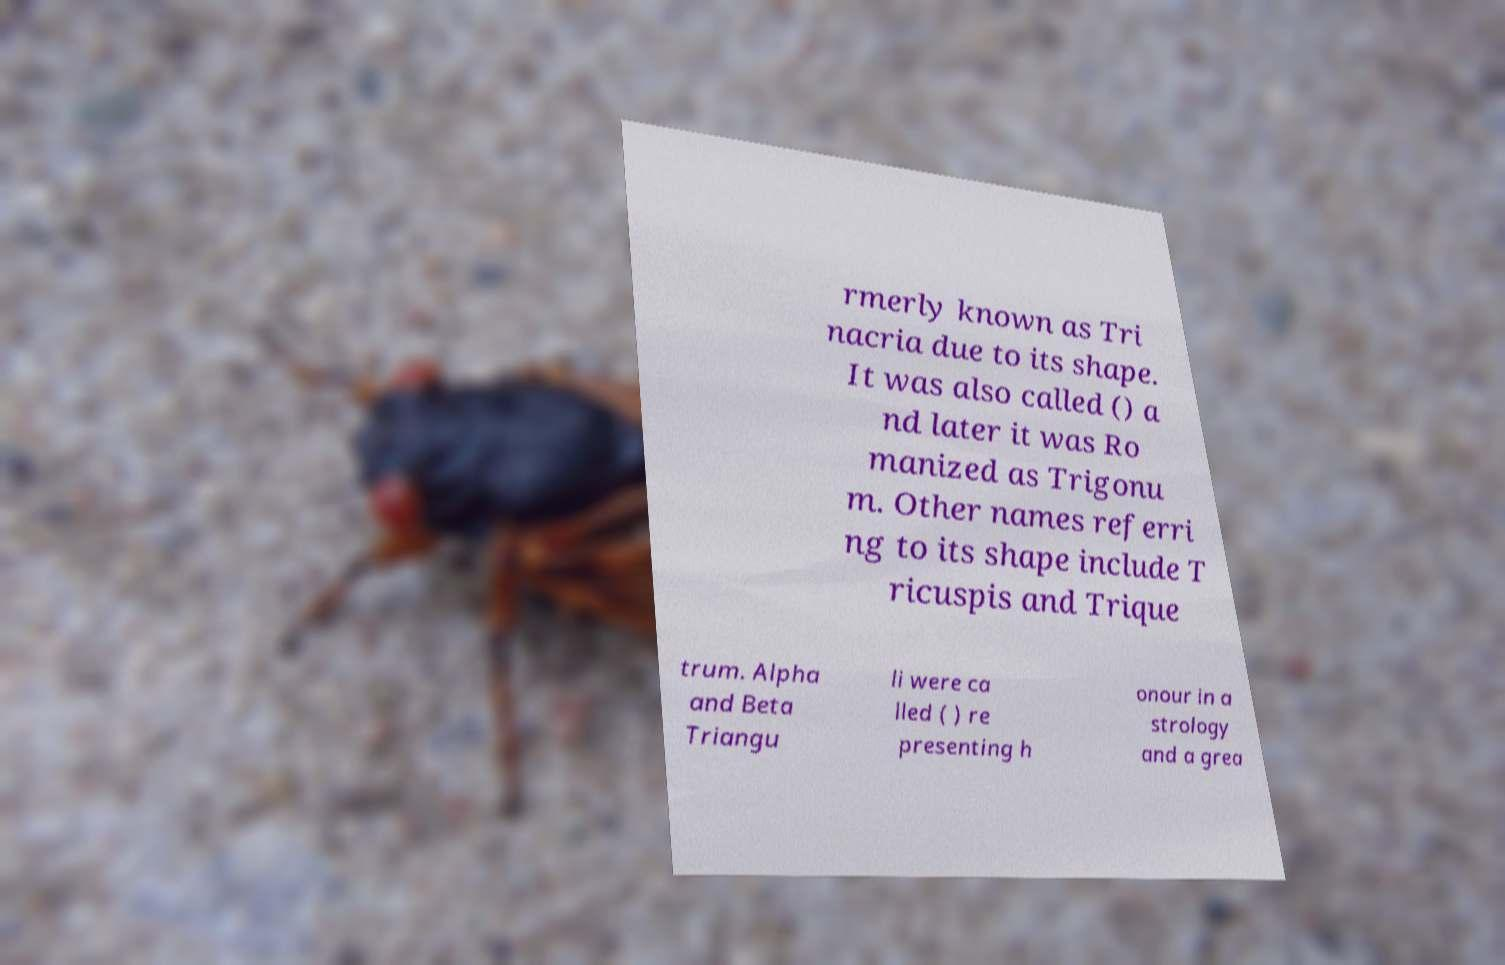Please read and relay the text visible in this image. What does it say? rmerly known as Tri nacria due to its shape. It was also called () a nd later it was Ro manized as Trigonu m. Other names referri ng to its shape include T ricuspis and Trique trum. Alpha and Beta Triangu li were ca lled ( ) re presenting h onour in a strology and a grea 